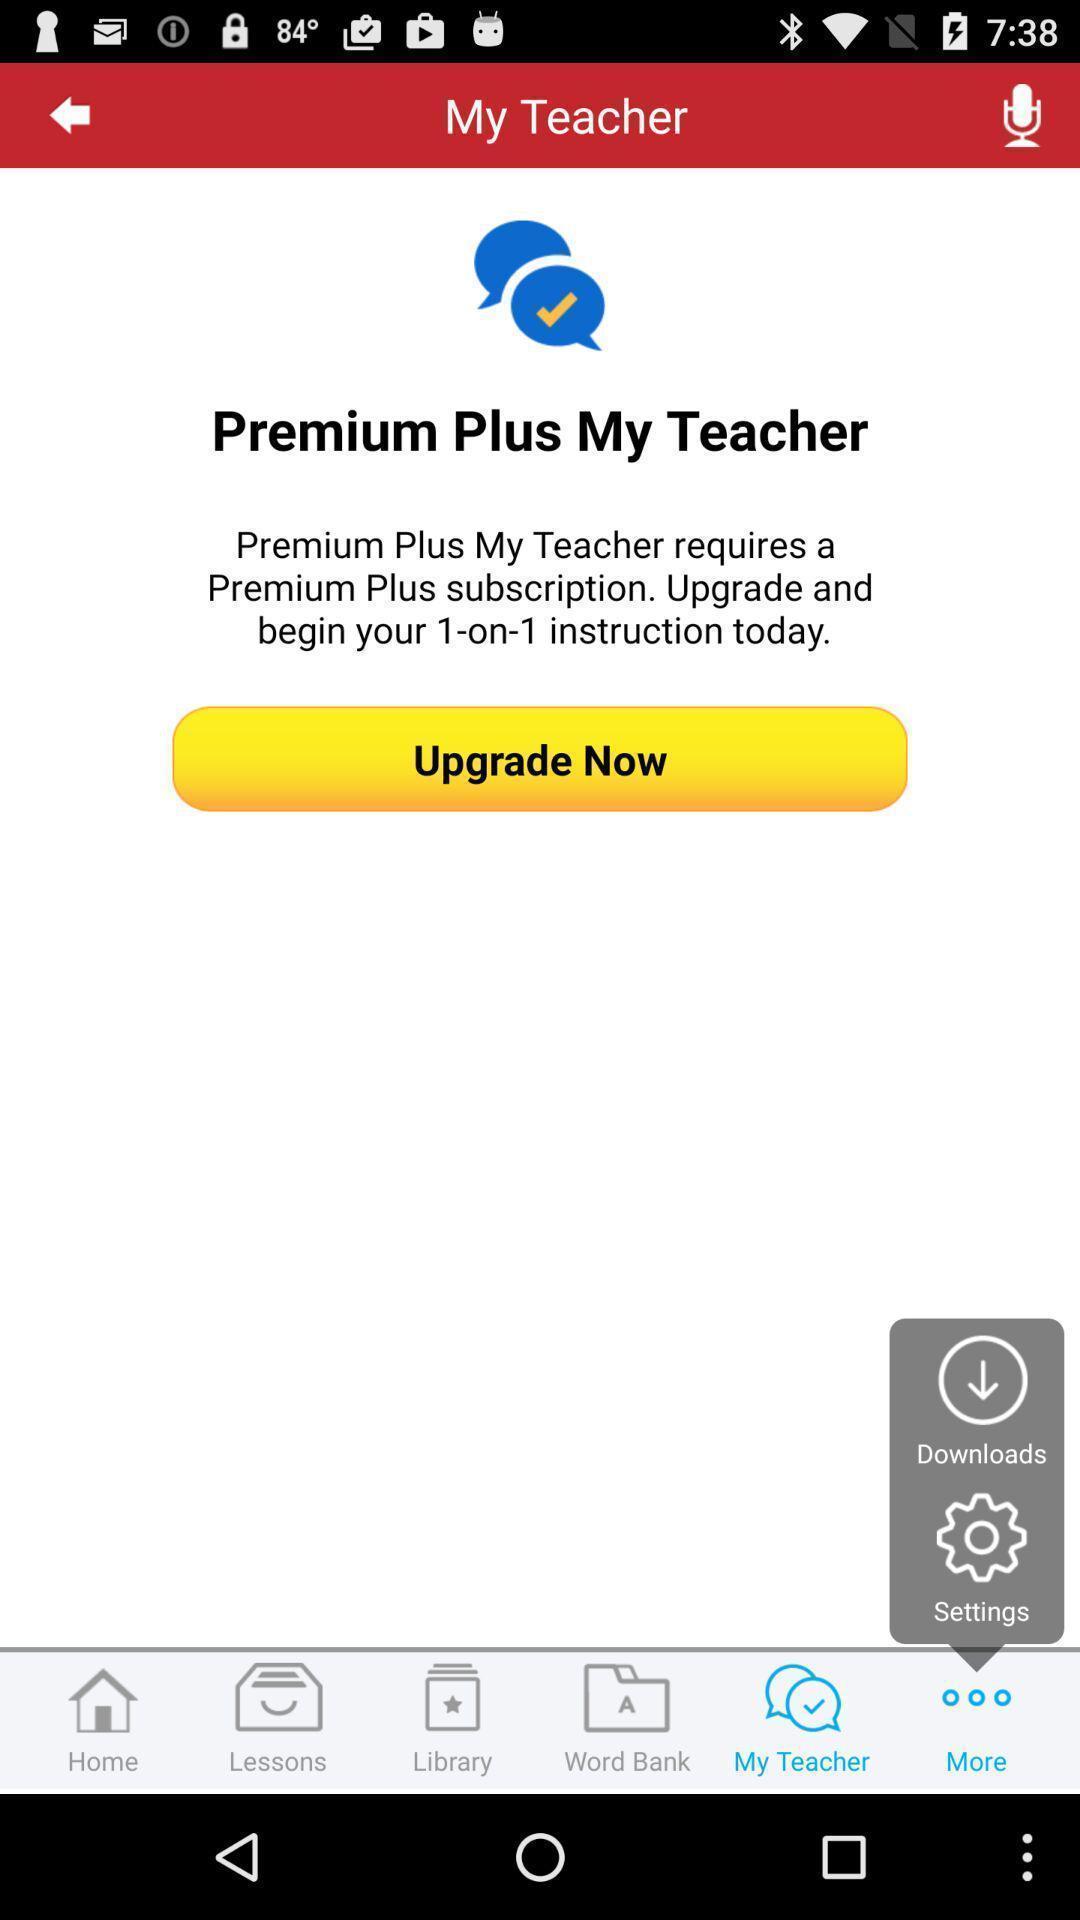Tell me about the visual elements in this screen capture. Screen showing the upgrade option in leaning app. 